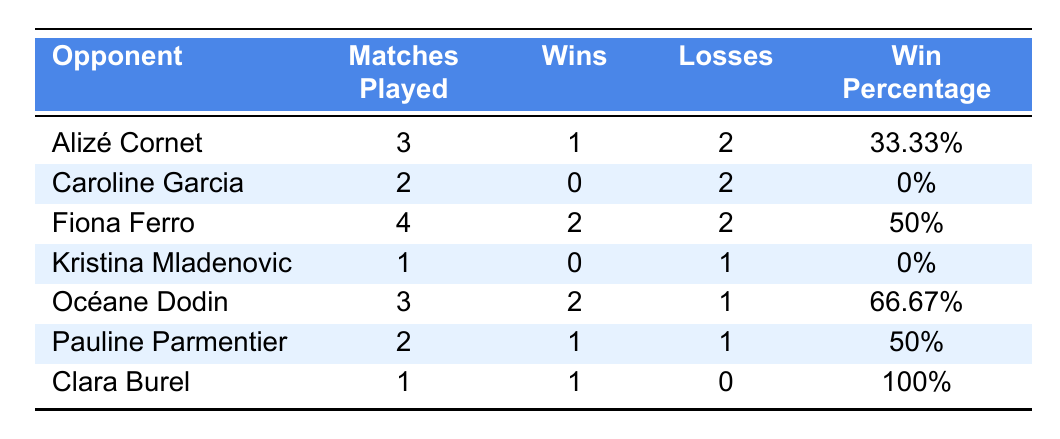What is Chloé Paquet's win percentage against Alizé Cornet? The table shows that Chloé Paquet has a win percentage of 33.33% against Alizé Cornet.
Answer: 33.33% How many matches has Chloé Paquet played against Caroline Garcia? According to the table, Chloé Paquet has played 2 matches against Caroline Garcia.
Answer: 2 Against which French opponent does Chloé Paquet have the highest win percentage? Clara Burel is the opponent with the highest win percentage at 100%, as Chloé Paquet won 1 out of 1 match played.
Answer: Clara Burel What is the total number of matches Chloé Paquet has played against French compatriots listed in the table? The total is calculated by adding the matches played against each listed opponent: 3 + 2 + 4 + 1 + 3 + 2 + 1 = 16 matches.
Answer: 16 How many matches has Chloé Paquet lost against Fiona Ferro? The table reveals that she lost 2 matches against Fiona Ferro.
Answer: 2 Did Chloé Paquet win more matches against Océane Dodin or Alizé Cornet? Chloé Paquet has 2 wins against Océane Dodin and 1 win against Alizé Cornet, which means she has more wins against Océane Dodin.
Answer: Océane Dodin What is the average win percentage for Chloé Paquet against her French counterparts? The win percentages are 33.33%, 0%, 50%, 0%, 66.67%, 50%, and 100%. Adding these gives 300% and dividing by 7 (the number of opponents) results in an average of approximately 42.86%.
Answer: 42.86% How many opponents has Chloé Paquet lost against? She lost against Caroline Garcia, Kristina Mladenovic, and Alizé Cornet, making it 3 opponents she lost to.
Answer: 3 True or False: Chloé Paquet has a better win percentage against Pauline Parmentier than against Fiona Ferro. Chloé Paquet has a win percentage of 50% against both Pauline Parmentier and Fiona Ferro, so the statement is false.
Answer: False What is the total number of wins Chloé Paquet has against all listed French opponents? The total number of wins can be calculated as 1 (Cornet) + 0 (Garcia) + 2 (Ferro) + 0 (Mladenovic) + 2 (Dodin) + 1 (Parmentier) + 1 (Burel) = 7 wins.
Answer: 7 